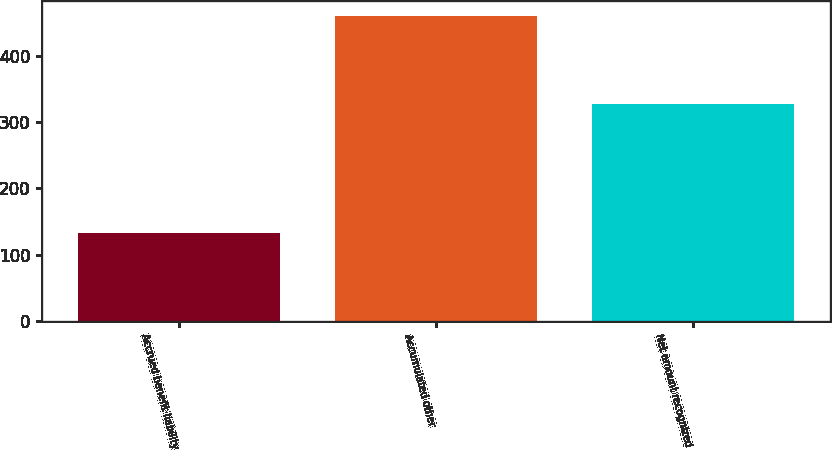<chart> <loc_0><loc_0><loc_500><loc_500><bar_chart><fcel>Accrued benefit liability<fcel>Accumulated other<fcel>Net amount recognized<nl><fcel>132<fcel>460<fcel>328<nl></chart> 